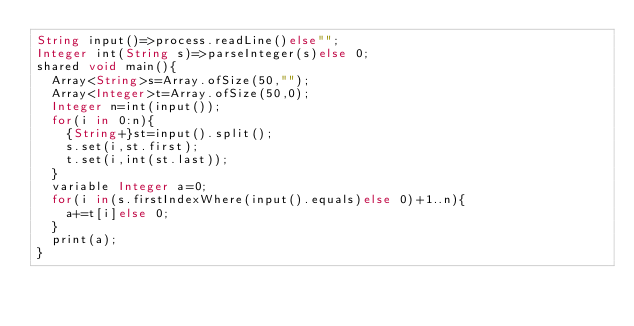Convert code to text. <code><loc_0><loc_0><loc_500><loc_500><_Ceylon_>String input()=>process.readLine()else""; 
Integer int(String s)=>parseInteger(s)else 0;
shared void main(){
  Array<String>s=Array.ofSize(50,"");
  Array<Integer>t=Array.ofSize(50,0);
  Integer n=int(input());
  for(i in 0:n){
    {String+}st=input().split();
    s.set(i,st.first);
    t.set(i,int(st.last));
  }
  variable Integer a=0;
  for(i in(s.firstIndexWhere(input().equals)else 0)+1..n){
    a+=t[i]else 0;
  }
  print(a);
}
</code> 